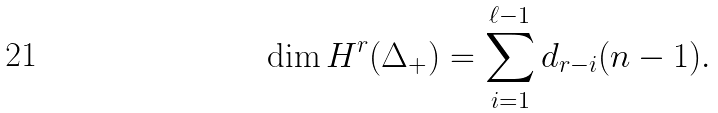<formula> <loc_0><loc_0><loc_500><loc_500>\dim H ^ { r } ( \Delta _ { + } ) = \sum _ { i = 1 } ^ { \ell - 1 } d _ { r - i } ( n - 1 ) .</formula> 